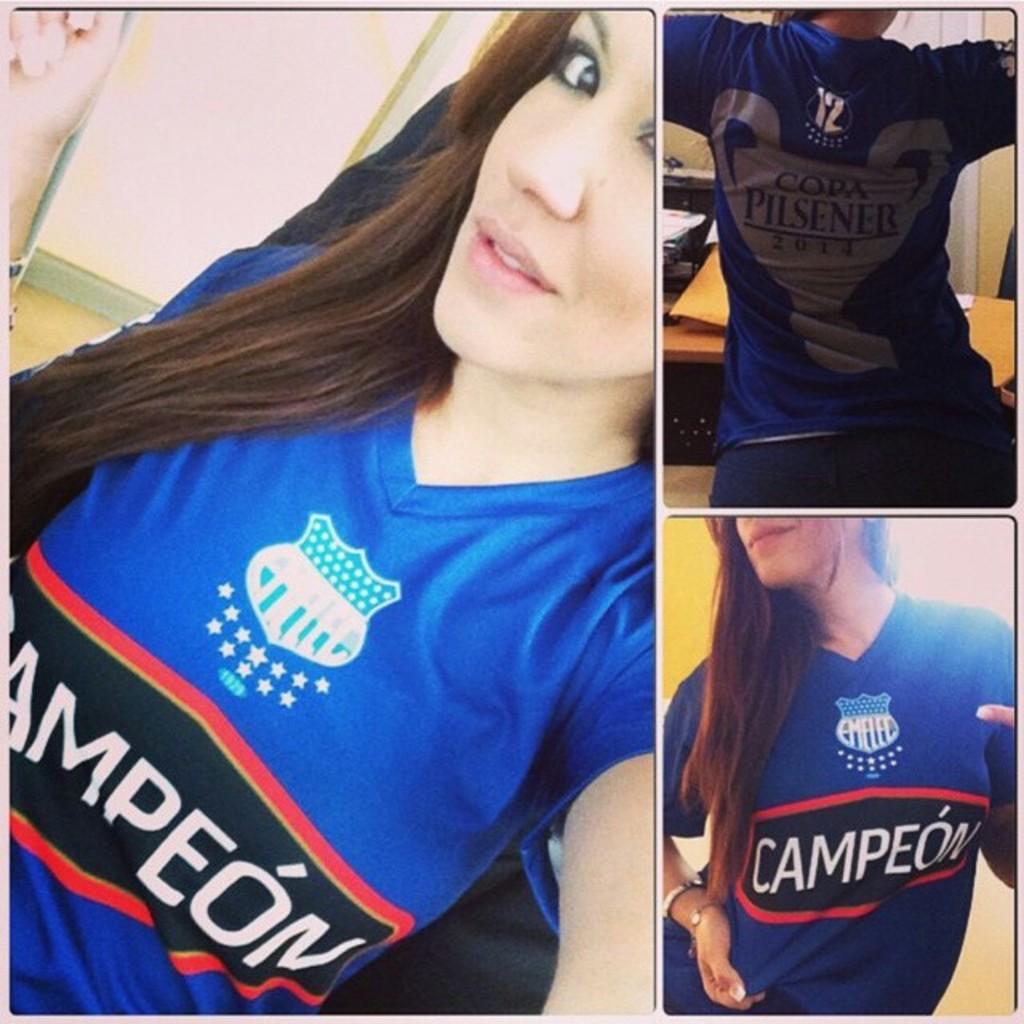Provide a one-sentence caption for the provided image. The girl shows off a sports top with the word Campeon written on it. 